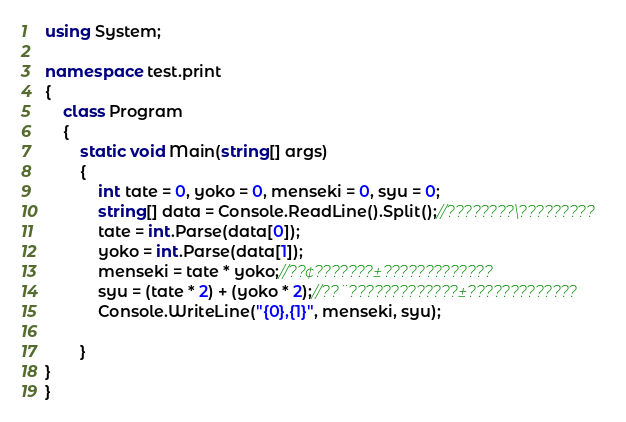<code> <loc_0><loc_0><loc_500><loc_500><_C#_>using System;

namespace test.print
{
    class Program
    {
        static void Main(string[] args)
        {
            int tate = 0, yoko = 0, menseki = 0, syu = 0;
            string[] data = Console.ReadLine().Split();//????????\?????????
            tate = int.Parse(data[0]);
            yoko = int.Parse(data[1]);
            menseki = tate * yoko;//??¢???????±?????????????
            syu = (tate * 2) + (yoko * 2);//??¨?????????????±?????????????
            Console.WriteLine("{0},{1}", menseki, syu);

        }
}
}</code> 